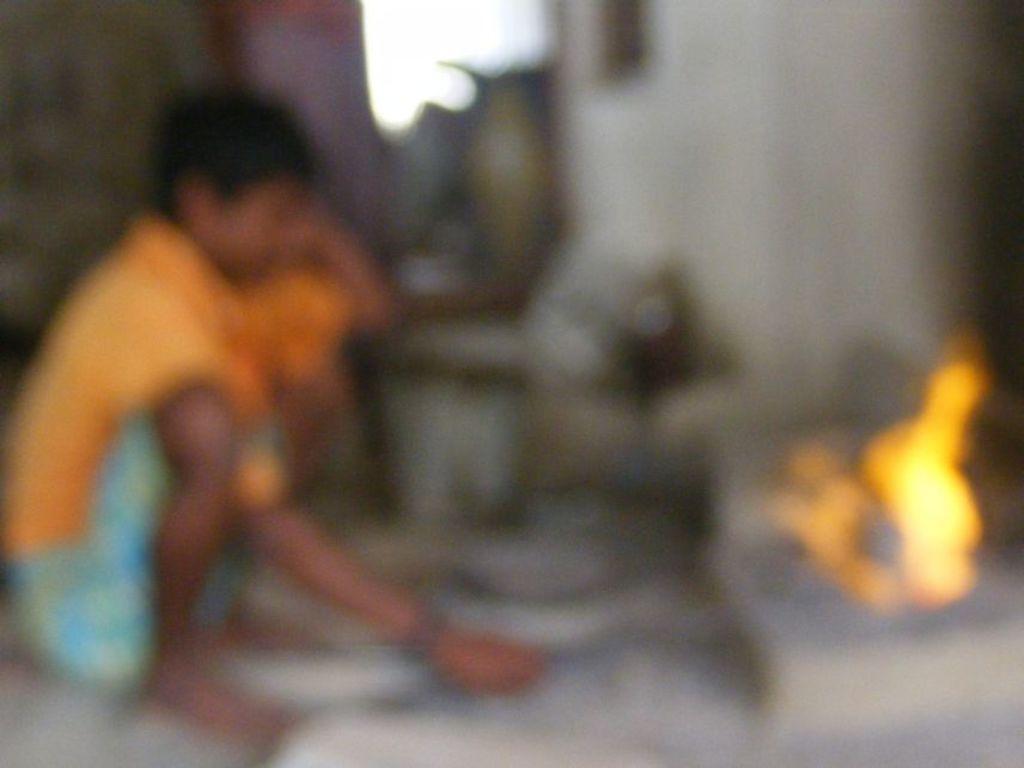In one or two sentences, can you explain what this image depicts? On the left side there is a boy who is in a squat position and holding a sticks. On the right we can see a fire. On the top there is a window. Here we can see some objects. 